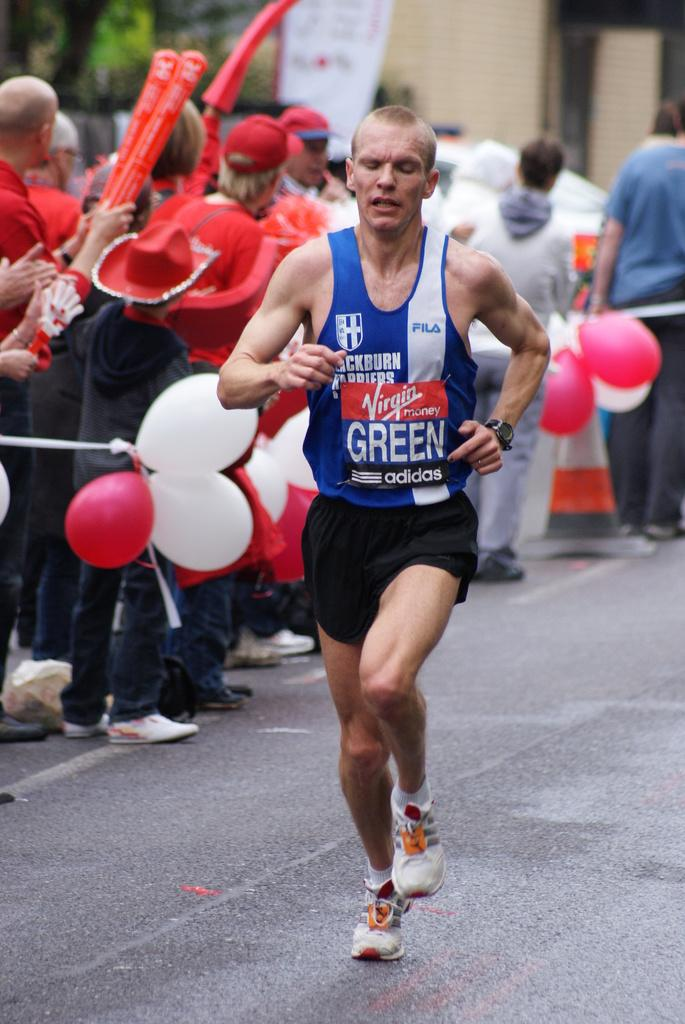<image>
Relay a brief, clear account of the picture shown. A man dressed in blue and black with the word green on his shirt. 